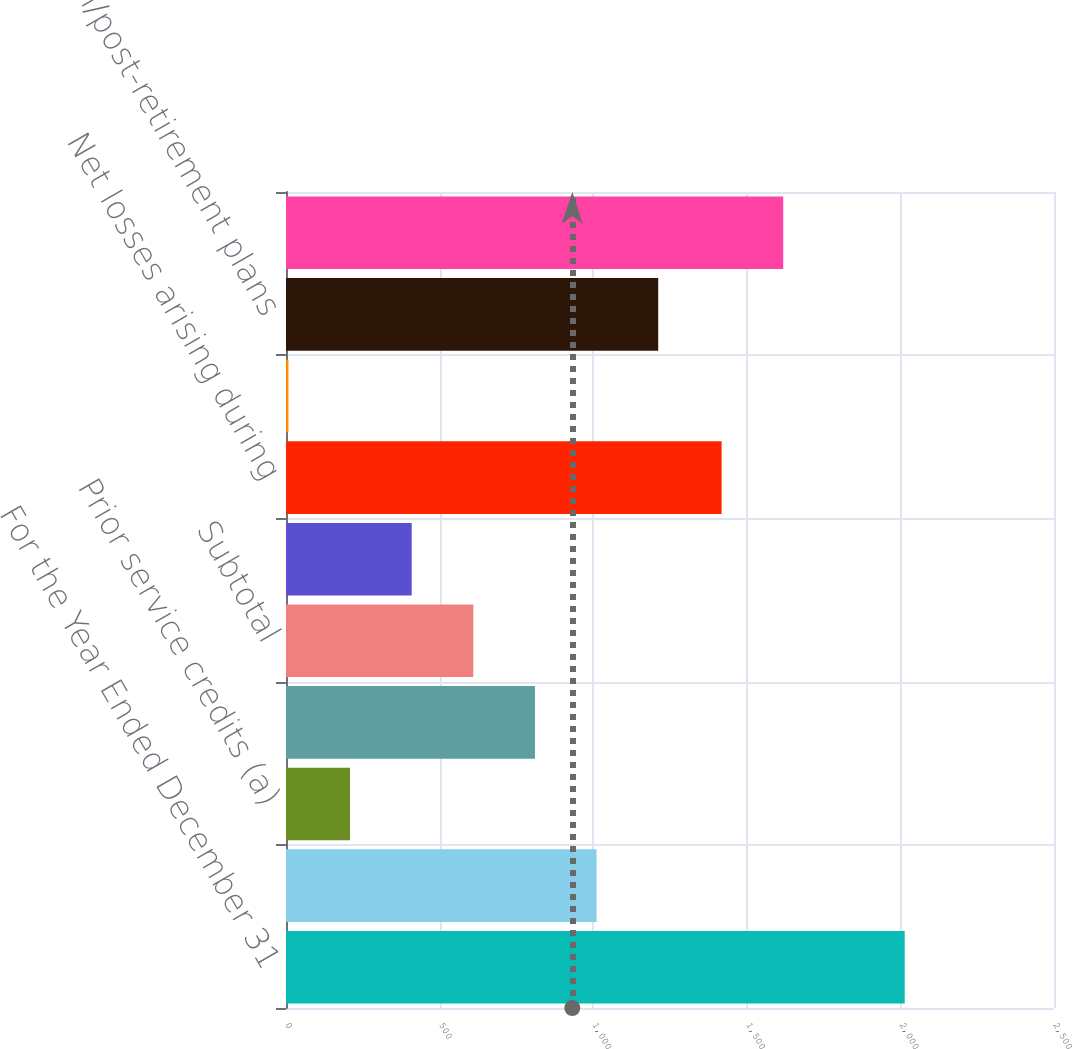<chart> <loc_0><loc_0><loc_500><loc_500><bar_chart><fcel>For the Year Ended December 31<fcel>Foreign currency translation<fcel>Prior service credits (a)<fcel>Net actuarial losses (a)<fcel>Subtotal<fcel>Effect of curtailment<fcel>Net losses arising during<fcel>Other adjustments<fcel>Pension/post-retirement plans<fcel>Other comprehensive loss<nl><fcel>2014<fcel>1011<fcel>208.6<fcel>810.4<fcel>609.8<fcel>409.2<fcel>1418<fcel>8<fcel>1211.6<fcel>1618.6<nl></chart> 